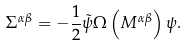Convert formula to latex. <formula><loc_0><loc_0><loc_500><loc_500>\Sigma ^ { \alpha \beta } = - \frac { 1 } { 2 } \tilde { \psi } \Omega \left ( M ^ { \alpha \beta } \right ) \psi .</formula> 